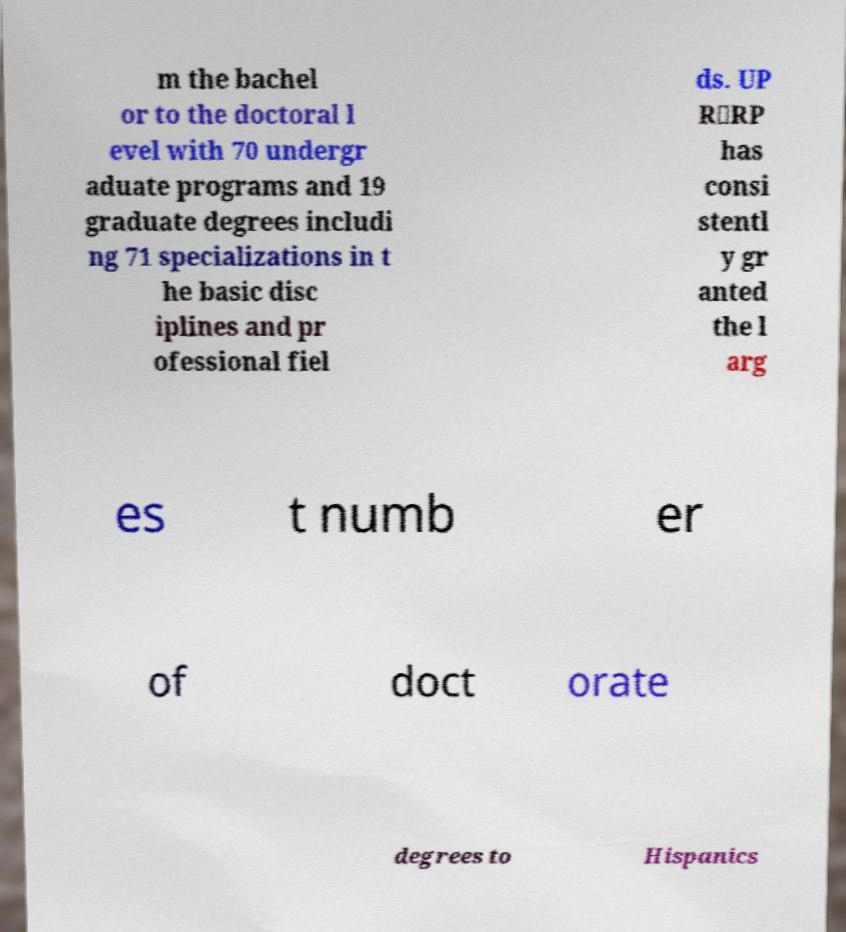Please identify and transcribe the text found in this image. m the bachel or to the doctoral l evel with 70 undergr aduate programs and 19 graduate degrees includi ng 71 specializations in t he basic disc iplines and pr ofessional fiel ds. UP R‐RP has consi stentl y gr anted the l arg es t numb er of doct orate degrees to Hispanics 